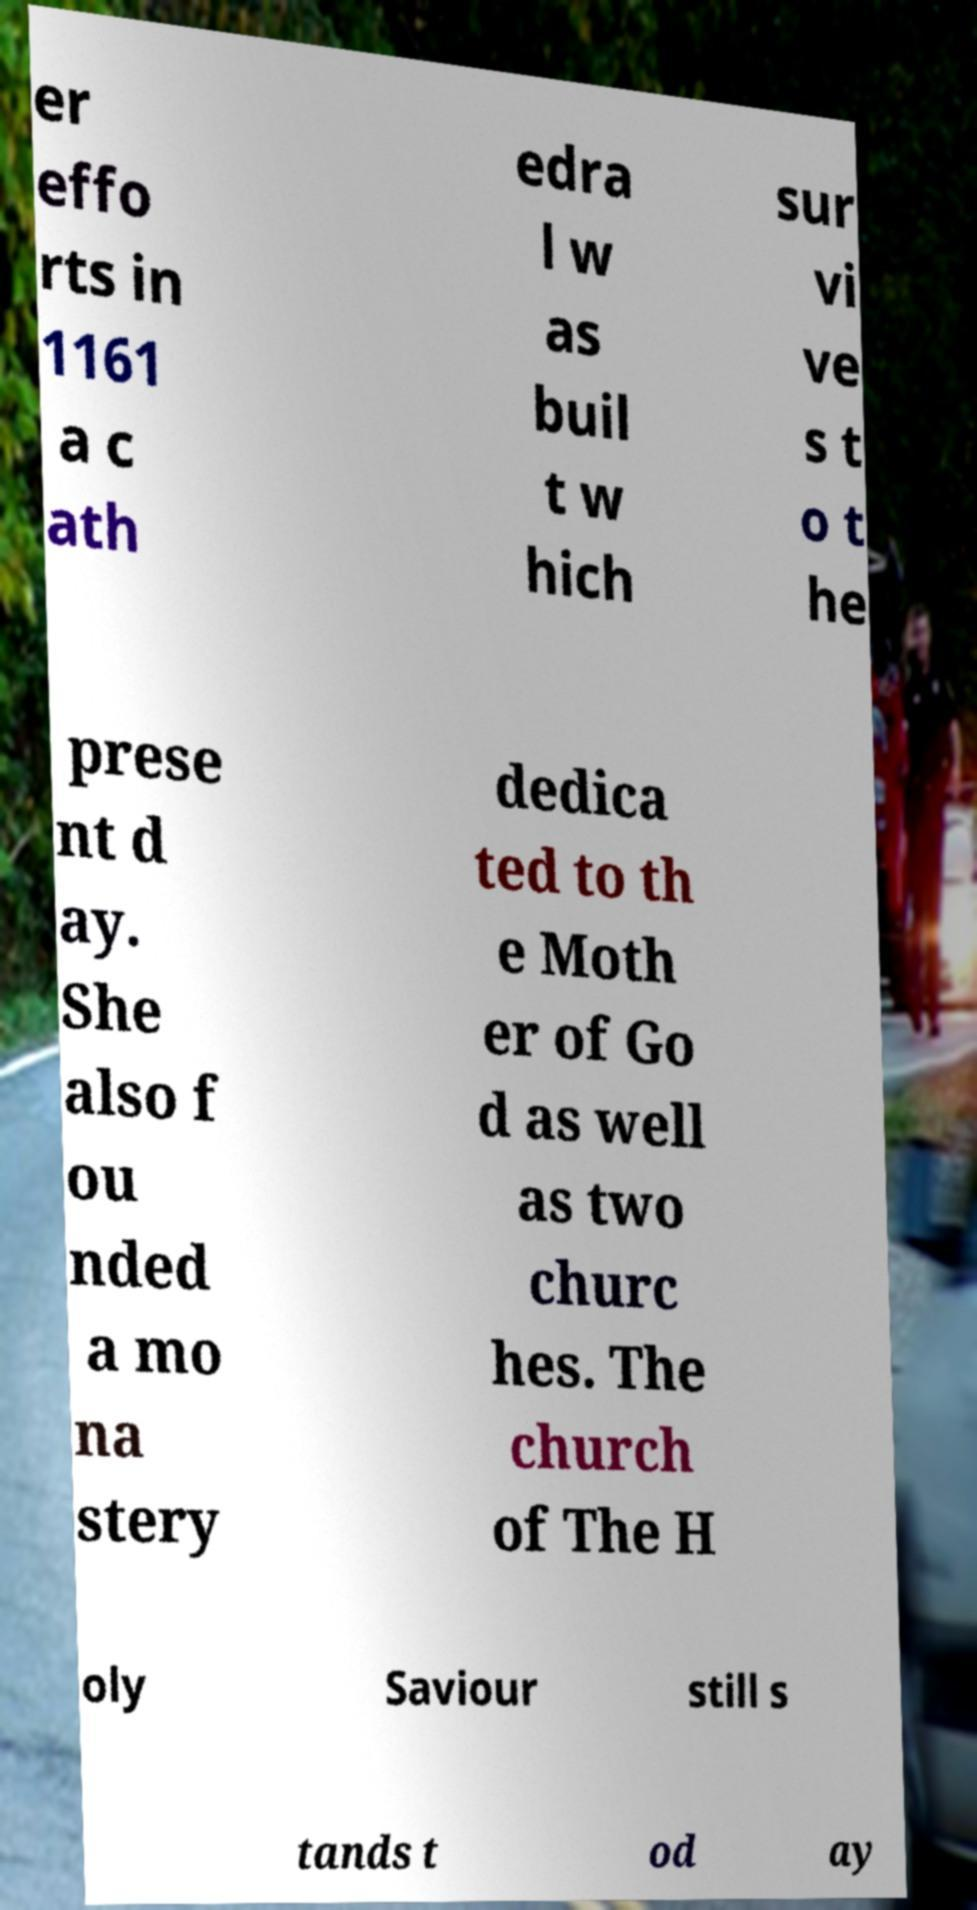Please read and relay the text visible in this image. What does it say? er effo rts in 1161 a c ath edra l w as buil t w hich sur vi ve s t o t he prese nt d ay. She also f ou nded a mo na stery dedica ted to th e Moth er of Go d as well as two churc hes. The church of The H oly Saviour still s tands t od ay 